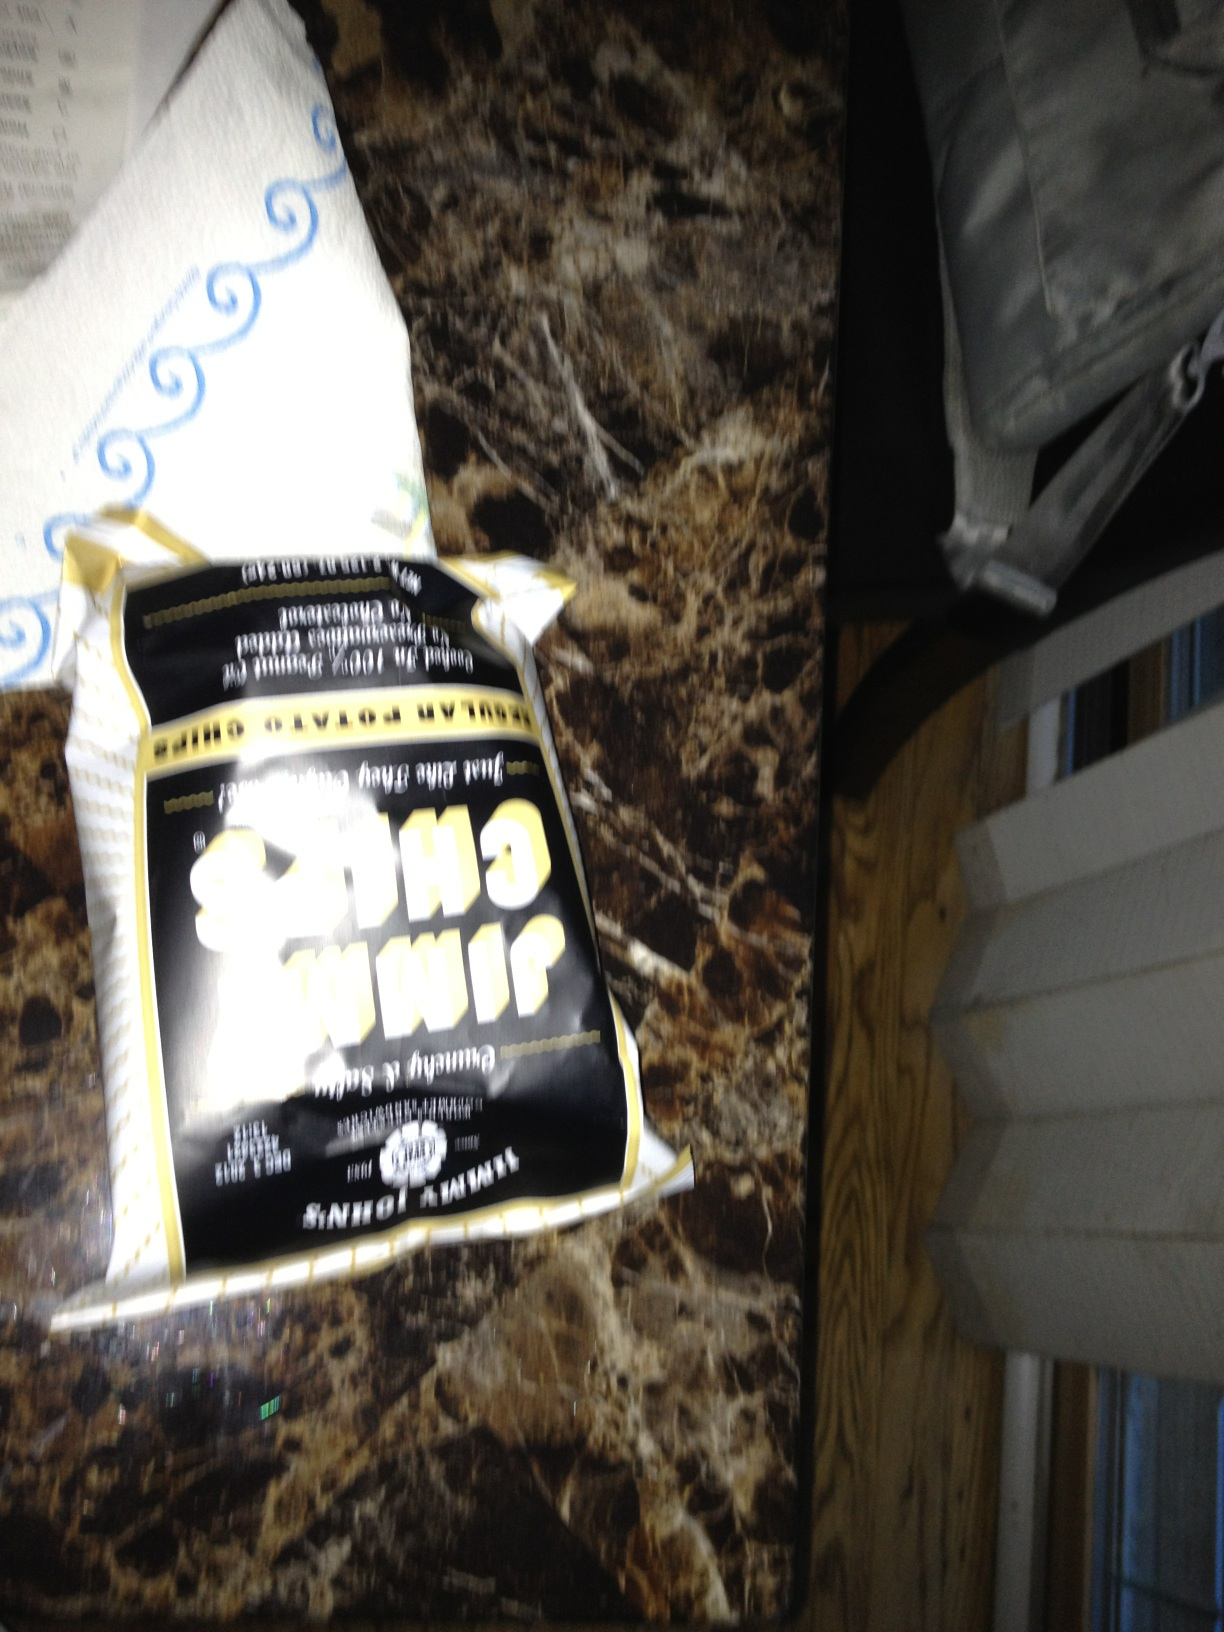What can you infer about the person who might eat these chips? Given that the chips bag is open, we can infer that the individual prefers this snack and might have been enjoying them recently. They may also have a liking for bold and strong flavors if we associate the dark packaging with such taste profiles. The casual manner in which the chips are placed could suggest a relaxed setting, perhaps during a break or leisure activity. 